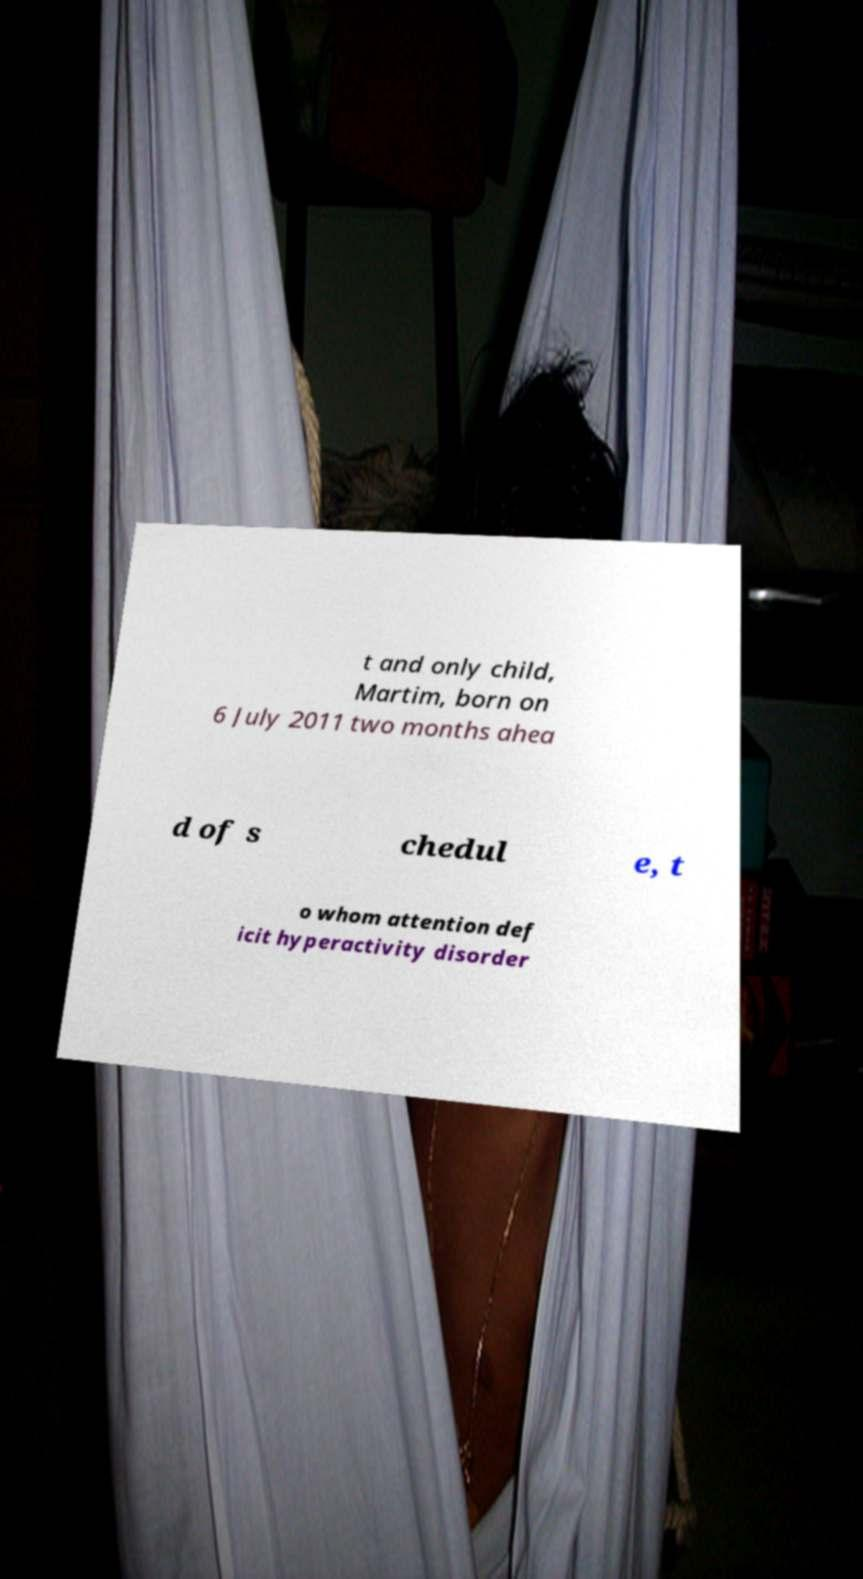Could you extract and type out the text from this image? t and only child, Martim, born on 6 July 2011 two months ahea d of s chedul e, t o whom attention def icit hyperactivity disorder 